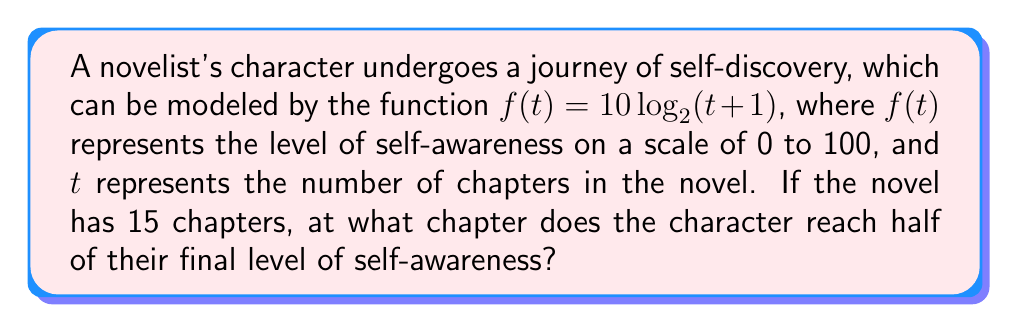Teach me how to tackle this problem. Let's approach this step-by-step:

1) First, we need to find the final level of self-awareness at the end of the novel (t = 15):
   $f(15) = 10 \log_2(15+1) = 10 \log_2(16) = 10 * 4 = 40$

2) Half of this final level would be:
   $40 / 2 = 20$

3) Now, we need to find at what value of $t$ the function equals 20:
   $20 = 10 \log_2(t+1)$

4) Divide both sides by 10:
   $2 = \log_2(t+1)$

5) Apply $2^x$ to both sides:
   $2^2 = 2^{\log_2(t+1)}$

6) Simplify:
   $4 = t+1$

7) Solve for $t$:
   $t = 3$

Therefore, the character reaches half of their final level of self-awareness at chapter 3.
Answer: 3 